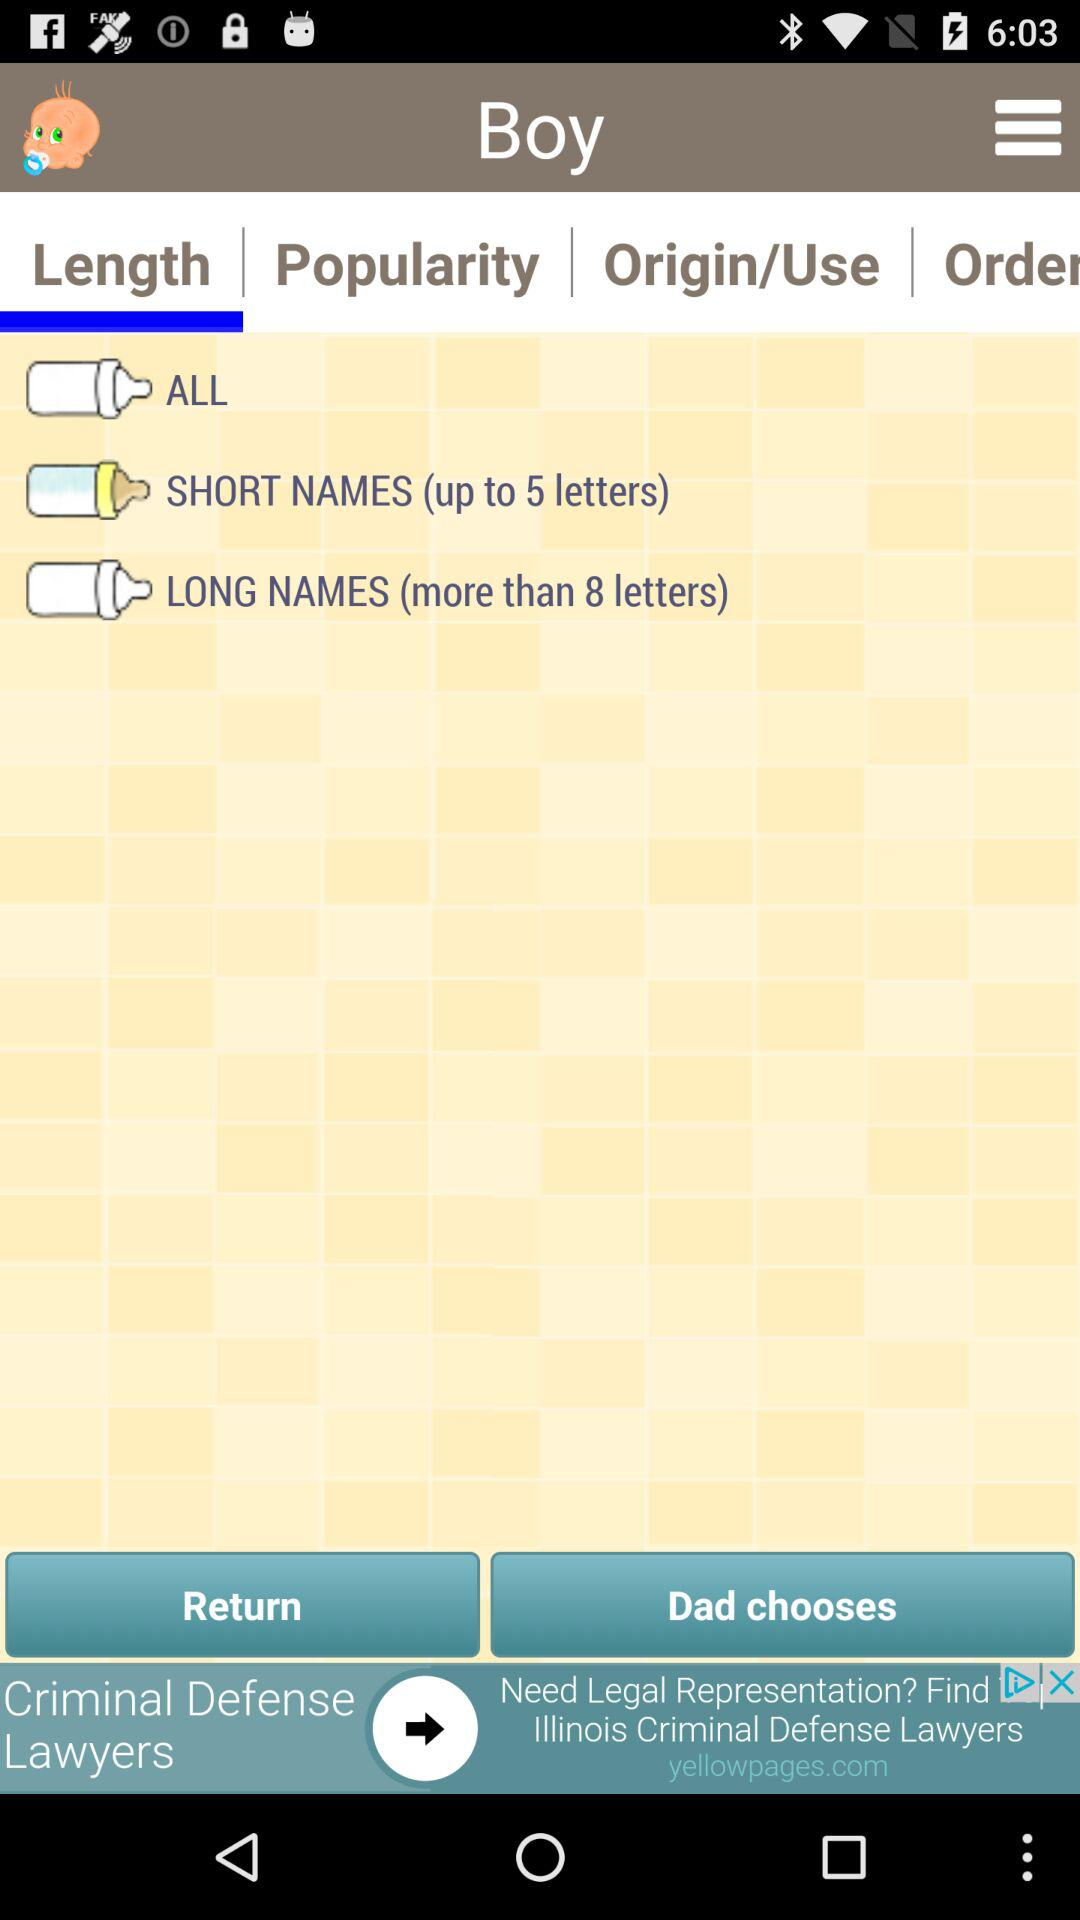Which boy names are popular?
When the provided information is insufficient, respond with <no answer>. <no answer> 